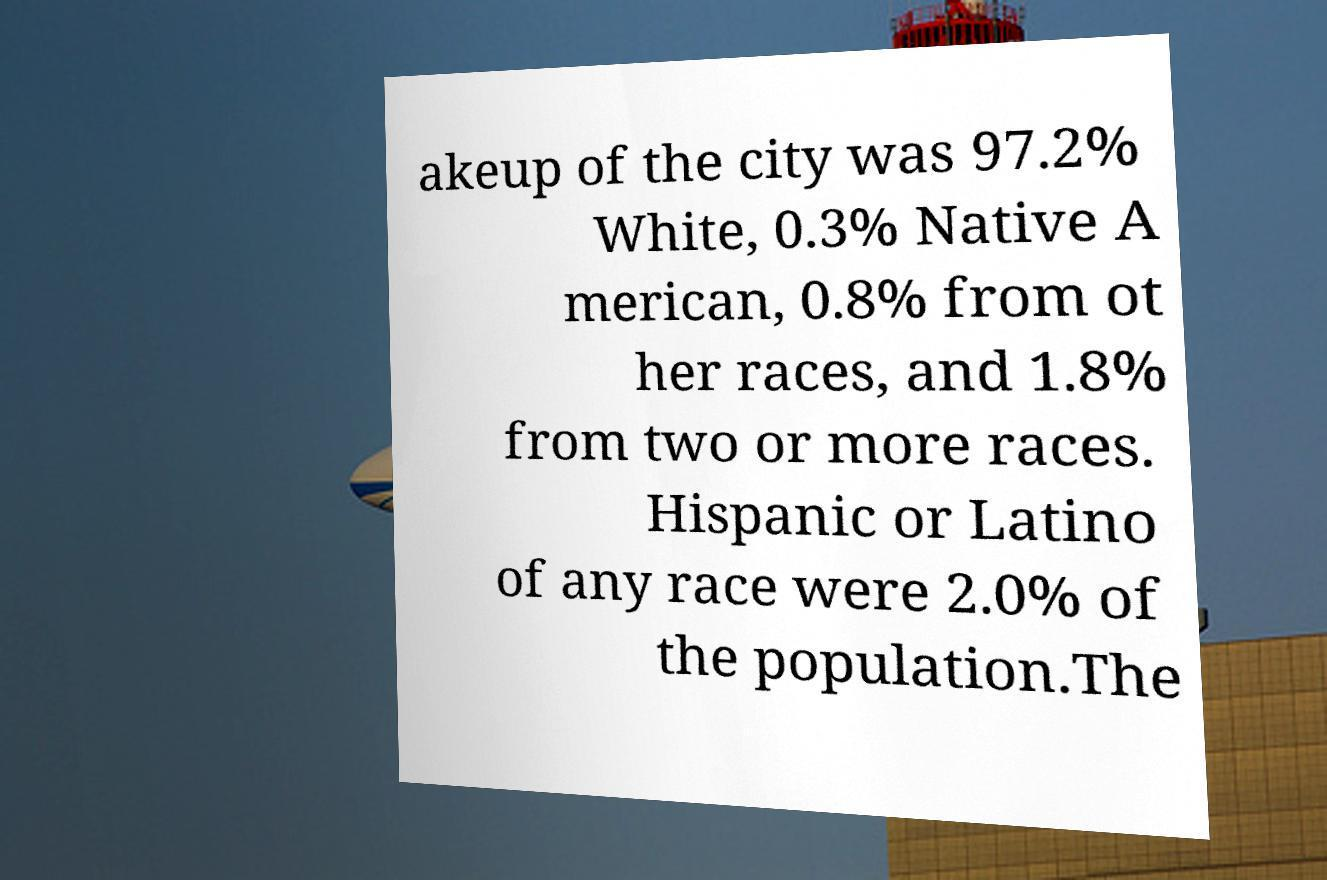There's text embedded in this image that I need extracted. Can you transcribe it verbatim? akeup of the city was 97.2% White, 0.3% Native A merican, 0.8% from ot her races, and 1.8% from two or more races. Hispanic or Latino of any race were 2.0% of the population.The 